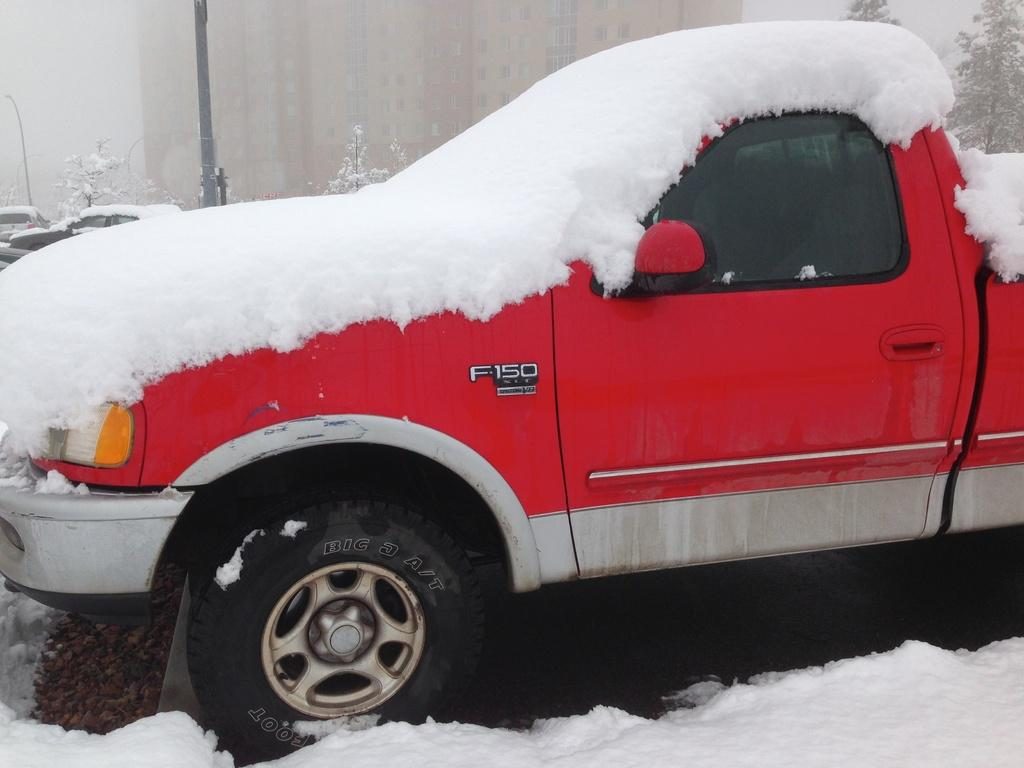<image>
Share a concise interpretation of the image provided. An F-150 red pick up truck covered in snow 